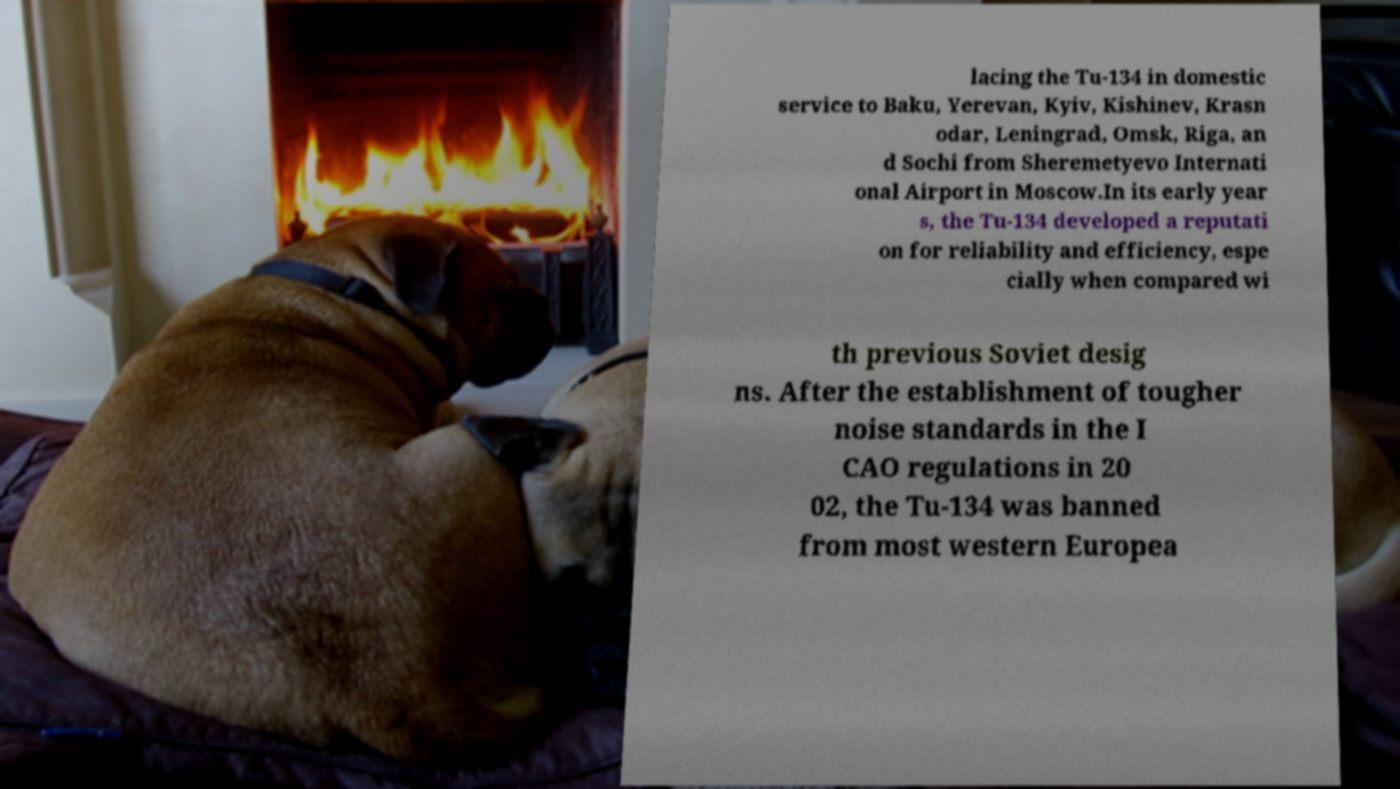Can you read and provide the text displayed in the image?This photo seems to have some interesting text. Can you extract and type it out for me? lacing the Tu-134 in domestic service to Baku, Yerevan, Kyiv, Kishinev, Krasn odar, Leningrad, Omsk, Riga, an d Sochi from Sheremetyevo Internati onal Airport in Moscow.In its early year s, the Tu-134 developed a reputati on for reliability and efficiency, espe cially when compared wi th previous Soviet desig ns. After the establishment of tougher noise standards in the I CAO regulations in 20 02, the Tu-134 was banned from most western Europea 